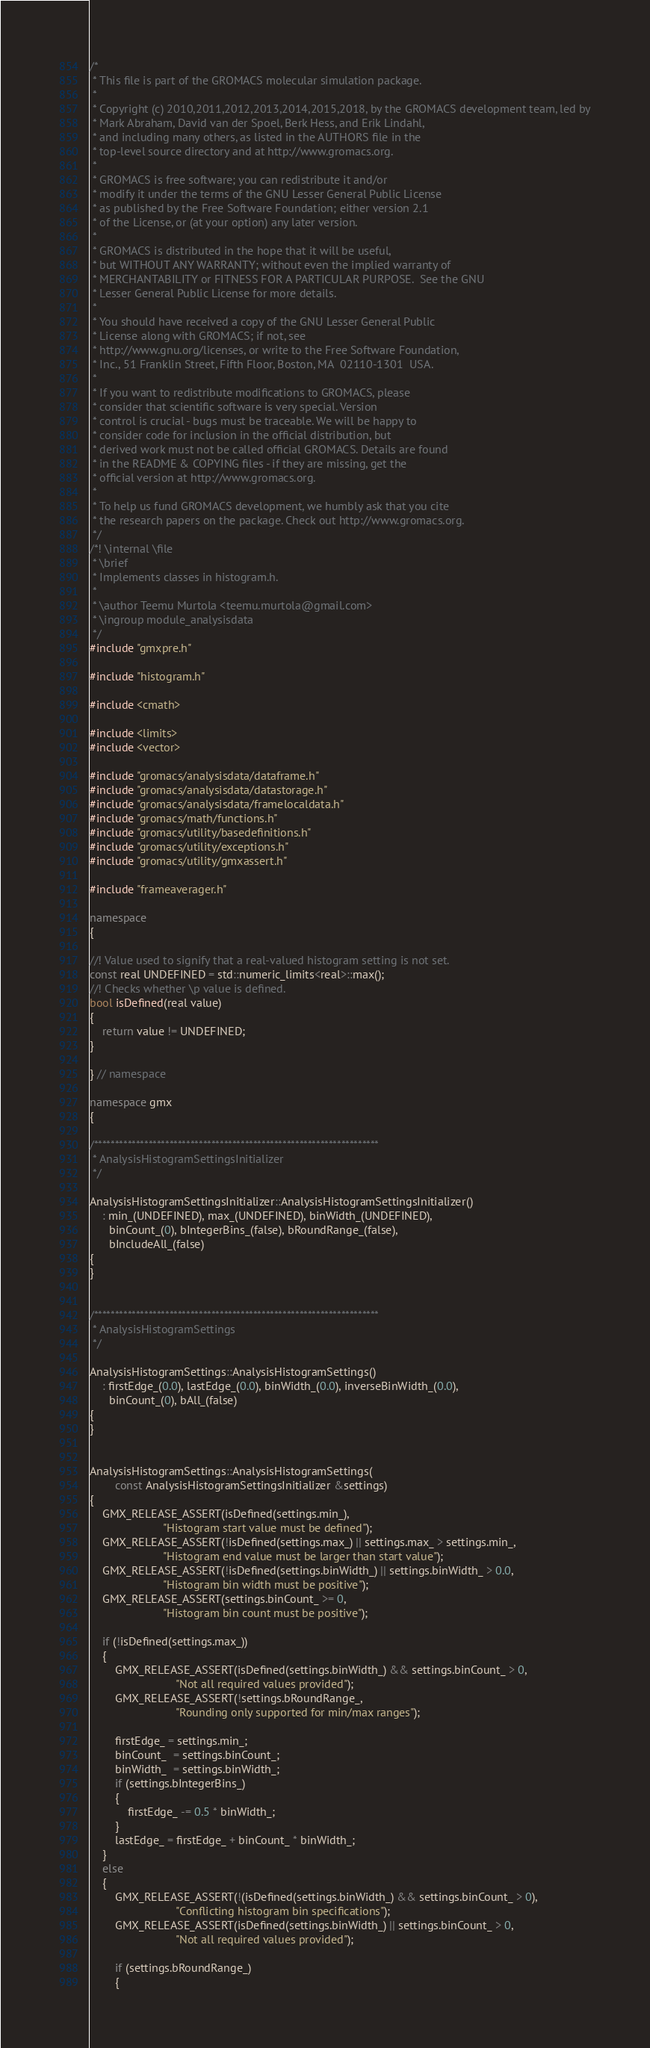<code> <loc_0><loc_0><loc_500><loc_500><_C++_>/*
 * This file is part of the GROMACS molecular simulation package.
 *
 * Copyright (c) 2010,2011,2012,2013,2014,2015,2018, by the GROMACS development team, led by
 * Mark Abraham, David van der Spoel, Berk Hess, and Erik Lindahl,
 * and including many others, as listed in the AUTHORS file in the
 * top-level source directory and at http://www.gromacs.org.
 *
 * GROMACS is free software; you can redistribute it and/or
 * modify it under the terms of the GNU Lesser General Public License
 * as published by the Free Software Foundation; either version 2.1
 * of the License, or (at your option) any later version.
 *
 * GROMACS is distributed in the hope that it will be useful,
 * but WITHOUT ANY WARRANTY; without even the implied warranty of
 * MERCHANTABILITY or FITNESS FOR A PARTICULAR PURPOSE.  See the GNU
 * Lesser General Public License for more details.
 *
 * You should have received a copy of the GNU Lesser General Public
 * License along with GROMACS; if not, see
 * http://www.gnu.org/licenses, or write to the Free Software Foundation,
 * Inc., 51 Franklin Street, Fifth Floor, Boston, MA  02110-1301  USA.
 *
 * If you want to redistribute modifications to GROMACS, please
 * consider that scientific software is very special. Version
 * control is crucial - bugs must be traceable. We will be happy to
 * consider code for inclusion in the official distribution, but
 * derived work must not be called official GROMACS. Details are found
 * in the README & COPYING files - if they are missing, get the
 * official version at http://www.gromacs.org.
 *
 * To help us fund GROMACS development, we humbly ask that you cite
 * the research papers on the package. Check out http://www.gromacs.org.
 */
/*! \internal \file
 * \brief
 * Implements classes in histogram.h.
 *
 * \author Teemu Murtola <teemu.murtola@gmail.com>
 * \ingroup module_analysisdata
 */
#include "gmxpre.h"

#include "histogram.h"

#include <cmath>

#include <limits>
#include <vector>

#include "gromacs/analysisdata/dataframe.h"
#include "gromacs/analysisdata/datastorage.h"
#include "gromacs/analysisdata/framelocaldata.h"
#include "gromacs/math/functions.h"
#include "gromacs/utility/basedefinitions.h"
#include "gromacs/utility/exceptions.h"
#include "gromacs/utility/gmxassert.h"

#include "frameaverager.h"

namespace
{

//! Value used to signify that a real-valued histogram setting is not set.
const real UNDEFINED = std::numeric_limits<real>::max();
//! Checks whether \p value is defined.
bool isDefined(real value)
{
    return value != UNDEFINED;
}

} // namespace

namespace gmx
{

/********************************************************************
 * AnalysisHistogramSettingsInitializer
 */

AnalysisHistogramSettingsInitializer::AnalysisHistogramSettingsInitializer()
    : min_(UNDEFINED), max_(UNDEFINED), binWidth_(UNDEFINED),
      binCount_(0), bIntegerBins_(false), bRoundRange_(false),
      bIncludeAll_(false)
{
}


/********************************************************************
 * AnalysisHistogramSettings
 */

AnalysisHistogramSettings::AnalysisHistogramSettings()
    : firstEdge_(0.0), lastEdge_(0.0), binWidth_(0.0), inverseBinWidth_(0.0),
      binCount_(0), bAll_(false)
{
}


AnalysisHistogramSettings::AnalysisHistogramSettings(
        const AnalysisHistogramSettingsInitializer &settings)
{
    GMX_RELEASE_ASSERT(isDefined(settings.min_),
                       "Histogram start value must be defined");
    GMX_RELEASE_ASSERT(!isDefined(settings.max_) || settings.max_ > settings.min_,
                       "Histogram end value must be larger than start value");
    GMX_RELEASE_ASSERT(!isDefined(settings.binWidth_) || settings.binWidth_ > 0.0,
                       "Histogram bin width must be positive");
    GMX_RELEASE_ASSERT(settings.binCount_ >= 0,
                       "Histogram bin count must be positive");

    if (!isDefined(settings.max_))
    {
        GMX_RELEASE_ASSERT(isDefined(settings.binWidth_) && settings.binCount_ > 0,
                           "Not all required values provided");
        GMX_RELEASE_ASSERT(!settings.bRoundRange_,
                           "Rounding only supported for min/max ranges");

        firstEdge_ = settings.min_;
        binCount_  = settings.binCount_;
        binWidth_  = settings.binWidth_;
        if (settings.bIntegerBins_)
        {
            firstEdge_ -= 0.5 * binWidth_;
        }
        lastEdge_ = firstEdge_ + binCount_ * binWidth_;
    }
    else
    {
        GMX_RELEASE_ASSERT(!(isDefined(settings.binWidth_) && settings.binCount_ > 0),
                           "Conflicting histogram bin specifications");
        GMX_RELEASE_ASSERT(isDefined(settings.binWidth_) || settings.binCount_ > 0,
                           "Not all required values provided");

        if (settings.bRoundRange_)
        {</code> 